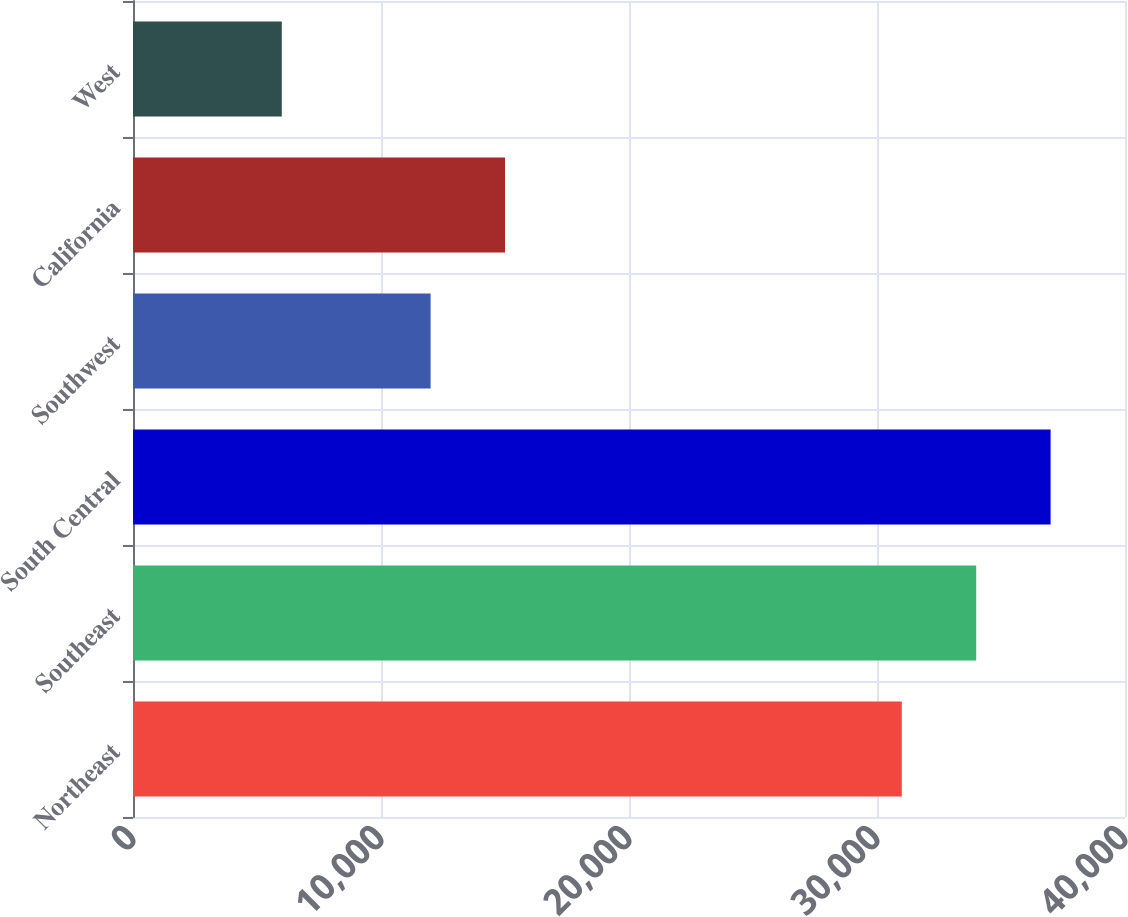Convert chart to OTSL. <chart><loc_0><loc_0><loc_500><loc_500><bar_chart><fcel>Northeast<fcel>Southeast<fcel>South Central<fcel>Southwest<fcel>California<fcel>West<nl><fcel>31000<fcel>34000<fcel>37000<fcel>12000<fcel>15000<fcel>6000<nl></chart> 